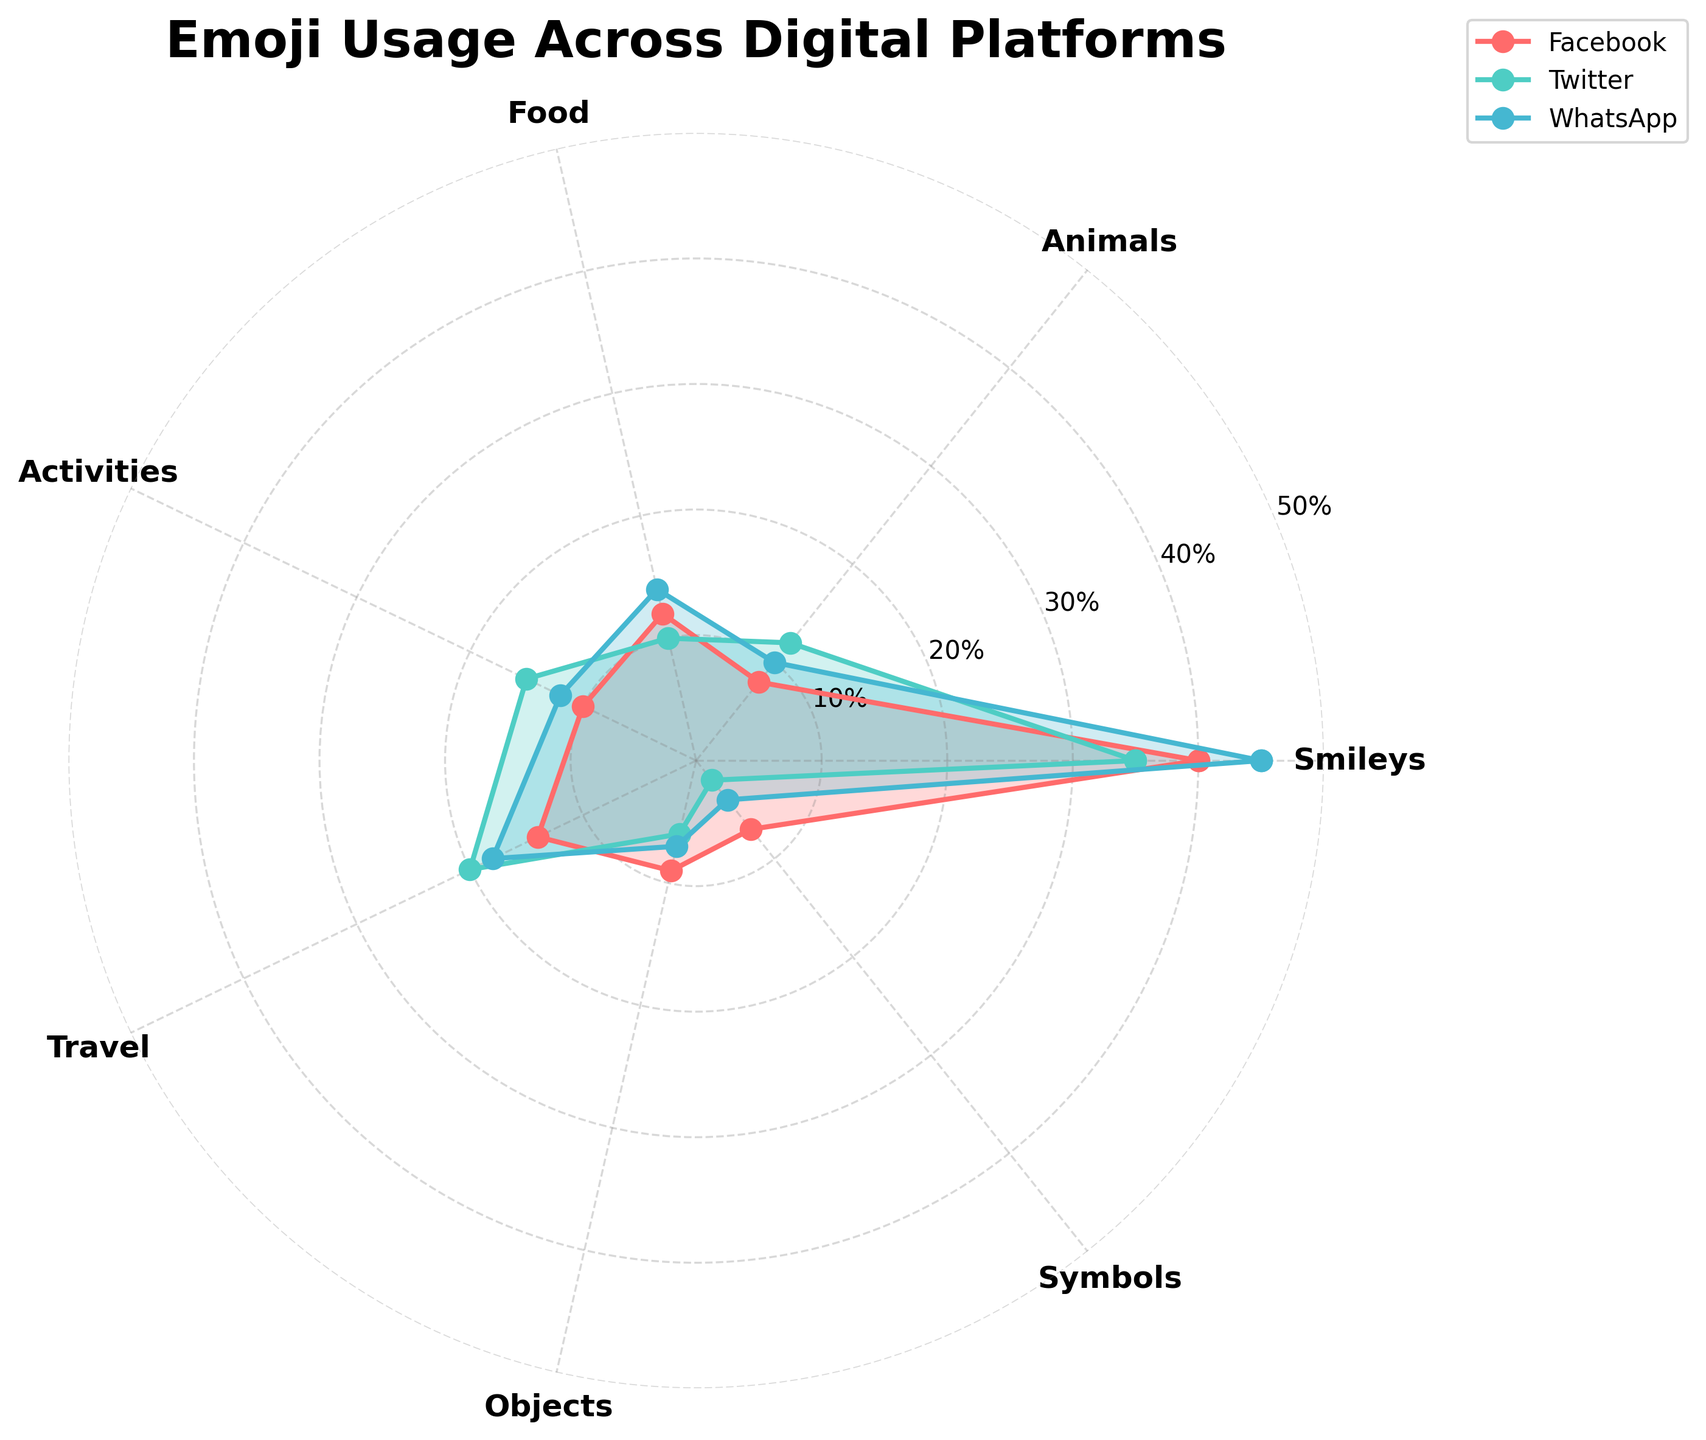What is the title of the chart? The title is located at the top of the chart and reads "Emoji Usage Across Digital Platforms".
Answer: Emoji Usage Across Digital Platforms Which platform uses the most "Smileys"? To find this, look at the "Smileys" section of the radar chart and observe which line extends the furthest. Facebook and WhatsApp both have the highest point in the "Smileys" section.
Answer: WhatsApp and Facebook How many platforms are compared in the chart? By counting the number of different colored lines on the chart, you can see there are three distinct platforms included.
Answer: 3 Which emoji category shows the least usage on Twitter? Locate the Twitter line and find the smallest value point; it corresponds to the "Symbols" category.
Answer: Symbols What is the difference in "Travel" emoji usage between WhatsApp and Email? Locate the points for WhatsApp (18%) and Email (3%) in the "Travel" category, then subtract the smaller value from the larger one (18 - 3).
Answer: 15% Which platform has the highest value in the "Activities" category? Identify the "Activities" category and see which line extends the furthest, which happens to be Twitter.
Answer: Twitter What's the average usage of "Objects" emojis across all platforms shown? The values are Facebook (9%), Twitter (6%), and WhatsApp (7%). Calculate the average: (9 + 6 + 7) / 3 = 22 / 3.
Answer: 7.33% Which platforms have a higher usage of "Animals" emojis compared to Email? Email has a value of 2% in the "Animals" category. Both Facebook (8%), Twitter (12%), and WhatsApp (10%) have higher values.
Answer: Facebook, Twitter, WhatsApp In which category is the difference between the highest and lowest usage the greatest? By comparing each category, "Smileys" ranges from the highest (WhatsApp 45%) to the lowest (Email 10%), giving a difference of 35%. The "Smileys" category has the greatest range.
Answer: Smileys 